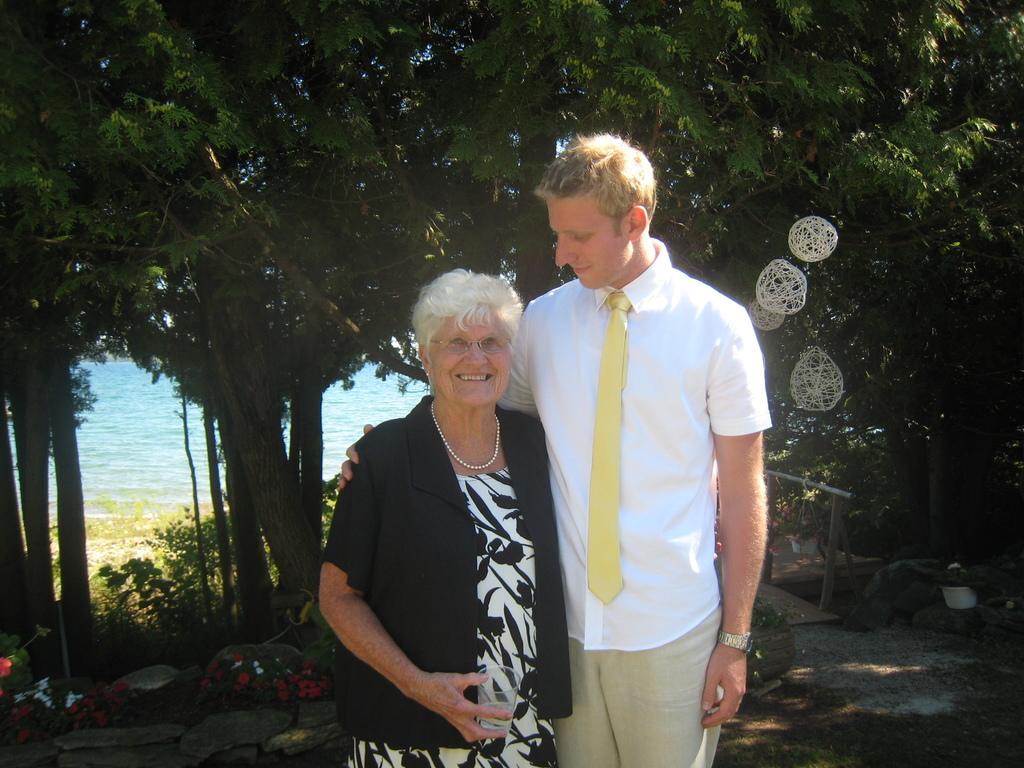In one or two sentences, can you explain what this image depicts? In this image we can see a man and a woman holding glass are standing. On the right side of the image we can see a container placed on the ground, some poles and some objects hanging on a tree. In the left side of the image we can see some flowers on the plants. In the background, we can see a group of trees and the water. 